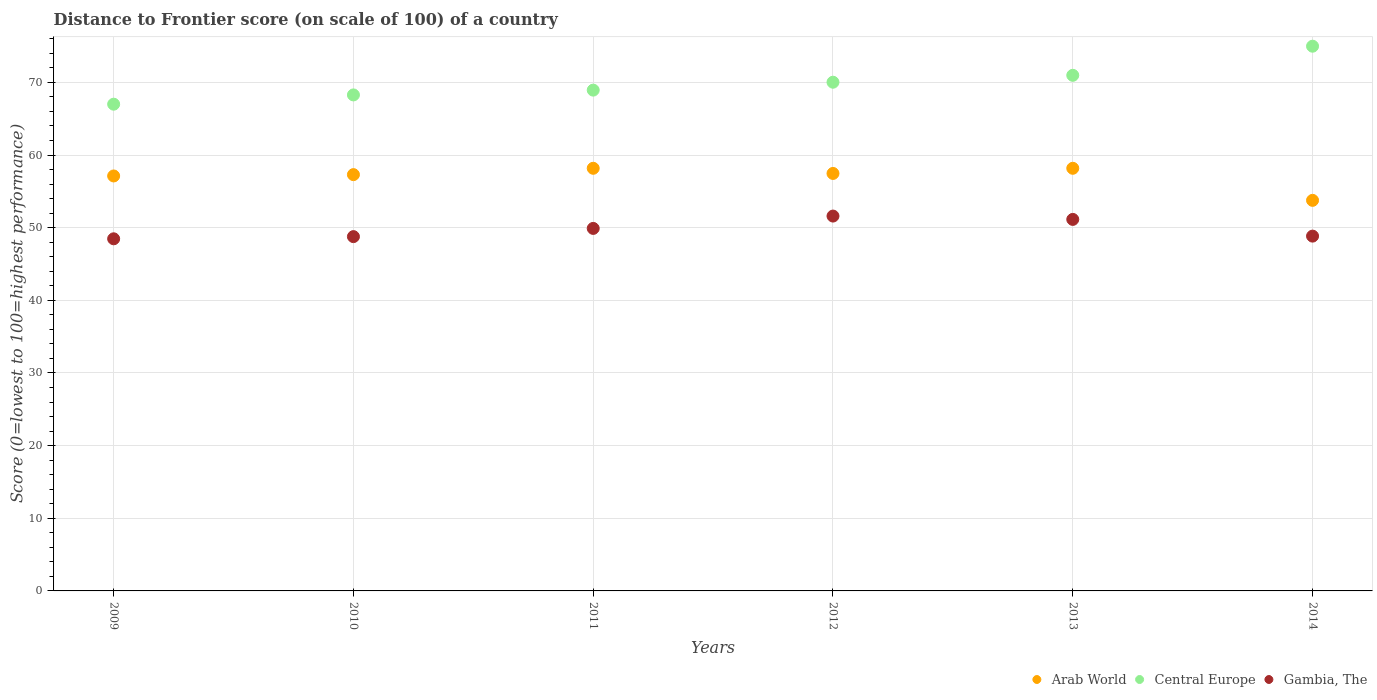How many different coloured dotlines are there?
Your answer should be very brief. 3. Is the number of dotlines equal to the number of legend labels?
Make the answer very short. Yes. What is the distance to frontier score of in Arab World in 2013?
Offer a terse response. 58.18. Across all years, what is the maximum distance to frontier score of in Central Europe?
Offer a very short reply. 74.98. Across all years, what is the minimum distance to frontier score of in Arab World?
Your answer should be very brief. 53.76. In which year was the distance to frontier score of in Central Europe minimum?
Make the answer very short. 2009. What is the total distance to frontier score of in Gambia, The in the graph?
Make the answer very short. 298.72. What is the difference between the distance to frontier score of in Central Europe in 2009 and that in 2012?
Your answer should be compact. -3.03. What is the difference between the distance to frontier score of in Arab World in 2014 and the distance to frontier score of in Gambia, The in 2009?
Offer a terse response. 5.29. What is the average distance to frontier score of in Arab World per year?
Provide a short and direct response. 57. In the year 2010, what is the difference between the distance to frontier score of in Central Europe and distance to frontier score of in Arab World?
Keep it short and to the point. 10.97. In how many years, is the distance to frontier score of in Central Europe greater than 20?
Provide a short and direct response. 6. What is the ratio of the distance to frontier score of in Arab World in 2009 to that in 2014?
Your answer should be compact. 1.06. Is the distance to frontier score of in Gambia, The in 2011 less than that in 2012?
Your answer should be very brief. Yes. What is the difference between the highest and the second highest distance to frontier score of in Arab World?
Provide a succinct answer. 0. What is the difference between the highest and the lowest distance to frontier score of in Gambia, The?
Make the answer very short. 3.13. Is it the case that in every year, the sum of the distance to frontier score of in Central Europe and distance to frontier score of in Gambia, The  is greater than the distance to frontier score of in Arab World?
Provide a succinct answer. Yes. What is the difference between two consecutive major ticks on the Y-axis?
Your response must be concise. 10. Are the values on the major ticks of Y-axis written in scientific E-notation?
Keep it short and to the point. No. How many legend labels are there?
Provide a succinct answer. 3. What is the title of the graph?
Give a very brief answer. Distance to Frontier score (on scale of 100) of a country. Does "Somalia" appear as one of the legend labels in the graph?
Offer a very short reply. No. What is the label or title of the X-axis?
Offer a very short reply. Years. What is the label or title of the Y-axis?
Your response must be concise. Score (0=lowest to 100=highest performance). What is the Score (0=lowest to 100=highest performance) in Arab World in 2009?
Offer a very short reply. 57.12. What is the Score (0=lowest to 100=highest performance) of Gambia, The in 2009?
Provide a short and direct response. 48.47. What is the Score (0=lowest to 100=highest performance) in Arab World in 2010?
Make the answer very short. 57.3. What is the Score (0=lowest to 100=highest performance) of Central Europe in 2010?
Keep it short and to the point. 68.28. What is the Score (0=lowest to 100=highest performance) in Gambia, The in 2010?
Your answer should be very brief. 48.77. What is the Score (0=lowest to 100=highest performance) of Arab World in 2011?
Your response must be concise. 58.18. What is the Score (0=lowest to 100=highest performance) of Central Europe in 2011?
Offer a terse response. 68.94. What is the Score (0=lowest to 100=highest performance) in Gambia, The in 2011?
Your response must be concise. 49.9. What is the Score (0=lowest to 100=highest performance) in Arab World in 2012?
Ensure brevity in your answer.  57.47. What is the Score (0=lowest to 100=highest performance) of Central Europe in 2012?
Ensure brevity in your answer.  70.03. What is the Score (0=lowest to 100=highest performance) in Gambia, The in 2012?
Your answer should be compact. 51.6. What is the Score (0=lowest to 100=highest performance) of Arab World in 2013?
Keep it short and to the point. 58.18. What is the Score (0=lowest to 100=highest performance) of Central Europe in 2013?
Give a very brief answer. 70.97. What is the Score (0=lowest to 100=highest performance) of Gambia, The in 2013?
Your answer should be very brief. 51.14. What is the Score (0=lowest to 100=highest performance) in Arab World in 2014?
Your response must be concise. 53.76. What is the Score (0=lowest to 100=highest performance) in Central Europe in 2014?
Ensure brevity in your answer.  74.98. What is the Score (0=lowest to 100=highest performance) of Gambia, The in 2014?
Give a very brief answer. 48.84. Across all years, what is the maximum Score (0=lowest to 100=highest performance) in Arab World?
Offer a very short reply. 58.18. Across all years, what is the maximum Score (0=lowest to 100=highest performance) in Central Europe?
Your response must be concise. 74.98. Across all years, what is the maximum Score (0=lowest to 100=highest performance) in Gambia, The?
Provide a short and direct response. 51.6. Across all years, what is the minimum Score (0=lowest to 100=highest performance) in Arab World?
Give a very brief answer. 53.76. Across all years, what is the minimum Score (0=lowest to 100=highest performance) in Central Europe?
Your answer should be compact. 67. Across all years, what is the minimum Score (0=lowest to 100=highest performance) of Gambia, The?
Offer a very short reply. 48.47. What is the total Score (0=lowest to 100=highest performance) in Arab World in the graph?
Your answer should be very brief. 342.01. What is the total Score (0=lowest to 100=highest performance) of Central Europe in the graph?
Offer a terse response. 420.19. What is the total Score (0=lowest to 100=highest performance) in Gambia, The in the graph?
Offer a very short reply. 298.72. What is the difference between the Score (0=lowest to 100=highest performance) of Arab World in 2009 and that in 2010?
Offer a terse response. -0.18. What is the difference between the Score (0=lowest to 100=highest performance) in Central Europe in 2009 and that in 2010?
Provide a short and direct response. -1.28. What is the difference between the Score (0=lowest to 100=highest performance) in Arab World in 2009 and that in 2011?
Offer a terse response. -1.06. What is the difference between the Score (0=lowest to 100=highest performance) in Central Europe in 2009 and that in 2011?
Provide a succinct answer. -1.94. What is the difference between the Score (0=lowest to 100=highest performance) of Gambia, The in 2009 and that in 2011?
Ensure brevity in your answer.  -1.43. What is the difference between the Score (0=lowest to 100=highest performance) in Arab World in 2009 and that in 2012?
Give a very brief answer. -0.35. What is the difference between the Score (0=lowest to 100=highest performance) of Central Europe in 2009 and that in 2012?
Offer a terse response. -3.03. What is the difference between the Score (0=lowest to 100=highest performance) in Gambia, The in 2009 and that in 2012?
Provide a short and direct response. -3.13. What is the difference between the Score (0=lowest to 100=highest performance) in Arab World in 2009 and that in 2013?
Ensure brevity in your answer.  -1.06. What is the difference between the Score (0=lowest to 100=highest performance) in Central Europe in 2009 and that in 2013?
Offer a very short reply. -3.97. What is the difference between the Score (0=lowest to 100=highest performance) in Gambia, The in 2009 and that in 2013?
Your response must be concise. -2.67. What is the difference between the Score (0=lowest to 100=highest performance) in Arab World in 2009 and that in 2014?
Offer a terse response. 3.36. What is the difference between the Score (0=lowest to 100=highest performance) in Central Europe in 2009 and that in 2014?
Give a very brief answer. -7.98. What is the difference between the Score (0=lowest to 100=highest performance) in Gambia, The in 2009 and that in 2014?
Your answer should be compact. -0.37. What is the difference between the Score (0=lowest to 100=highest performance) of Arab World in 2010 and that in 2011?
Provide a succinct answer. -0.87. What is the difference between the Score (0=lowest to 100=highest performance) of Central Europe in 2010 and that in 2011?
Ensure brevity in your answer.  -0.66. What is the difference between the Score (0=lowest to 100=highest performance) of Gambia, The in 2010 and that in 2011?
Keep it short and to the point. -1.13. What is the difference between the Score (0=lowest to 100=highest performance) of Arab World in 2010 and that in 2012?
Your answer should be very brief. -0.16. What is the difference between the Score (0=lowest to 100=highest performance) in Central Europe in 2010 and that in 2012?
Keep it short and to the point. -1.75. What is the difference between the Score (0=lowest to 100=highest performance) of Gambia, The in 2010 and that in 2012?
Keep it short and to the point. -2.83. What is the difference between the Score (0=lowest to 100=highest performance) in Arab World in 2010 and that in 2013?
Ensure brevity in your answer.  -0.87. What is the difference between the Score (0=lowest to 100=highest performance) in Central Europe in 2010 and that in 2013?
Your response must be concise. -2.7. What is the difference between the Score (0=lowest to 100=highest performance) in Gambia, The in 2010 and that in 2013?
Provide a succinct answer. -2.37. What is the difference between the Score (0=lowest to 100=highest performance) of Arab World in 2010 and that in 2014?
Keep it short and to the point. 3.54. What is the difference between the Score (0=lowest to 100=highest performance) of Central Europe in 2010 and that in 2014?
Your answer should be very brief. -6.71. What is the difference between the Score (0=lowest to 100=highest performance) of Gambia, The in 2010 and that in 2014?
Offer a terse response. -0.07. What is the difference between the Score (0=lowest to 100=highest performance) in Arab World in 2011 and that in 2012?
Offer a terse response. 0.71. What is the difference between the Score (0=lowest to 100=highest performance) of Central Europe in 2011 and that in 2012?
Give a very brief answer. -1.09. What is the difference between the Score (0=lowest to 100=highest performance) in Gambia, The in 2011 and that in 2012?
Your answer should be compact. -1.7. What is the difference between the Score (0=lowest to 100=highest performance) in Arab World in 2011 and that in 2013?
Give a very brief answer. 0. What is the difference between the Score (0=lowest to 100=highest performance) of Central Europe in 2011 and that in 2013?
Provide a short and direct response. -2.04. What is the difference between the Score (0=lowest to 100=highest performance) in Gambia, The in 2011 and that in 2013?
Your response must be concise. -1.24. What is the difference between the Score (0=lowest to 100=highest performance) of Arab World in 2011 and that in 2014?
Your answer should be very brief. 4.41. What is the difference between the Score (0=lowest to 100=highest performance) of Central Europe in 2011 and that in 2014?
Provide a succinct answer. -6.05. What is the difference between the Score (0=lowest to 100=highest performance) in Gambia, The in 2011 and that in 2014?
Your response must be concise. 1.06. What is the difference between the Score (0=lowest to 100=highest performance) in Arab World in 2012 and that in 2013?
Your answer should be compact. -0.71. What is the difference between the Score (0=lowest to 100=highest performance) of Central Europe in 2012 and that in 2013?
Your response must be concise. -0.95. What is the difference between the Score (0=lowest to 100=highest performance) in Gambia, The in 2012 and that in 2013?
Your response must be concise. 0.46. What is the difference between the Score (0=lowest to 100=highest performance) of Arab World in 2012 and that in 2014?
Your answer should be compact. 3.7. What is the difference between the Score (0=lowest to 100=highest performance) of Central Europe in 2012 and that in 2014?
Make the answer very short. -4.96. What is the difference between the Score (0=lowest to 100=highest performance) in Gambia, The in 2012 and that in 2014?
Offer a very short reply. 2.76. What is the difference between the Score (0=lowest to 100=highest performance) of Arab World in 2013 and that in 2014?
Ensure brevity in your answer.  4.41. What is the difference between the Score (0=lowest to 100=highest performance) in Central Europe in 2013 and that in 2014?
Offer a terse response. -4.01. What is the difference between the Score (0=lowest to 100=highest performance) in Gambia, The in 2013 and that in 2014?
Keep it short and to the point. 2.3. What is the difference between the Score (0=lowest to 100=highest performance) in Arab World in 2009 and the Score (0=lowest to 100=highest performance) in Central Europe in 2010?
Make the answer very short. -11.16. What is the difference between the Score (0=lowest to 100=highest performance) in Arab World in 2009 and the Score (0=lowest to 100=highest performance) in Gambia, The in 2010?
Your response must be concise. 8.35. What is the difference between the Score (0=lowest to 100=highest performance) of Central Europe in 2009 and the Score (0=lowest to 100=highest performance) of Gambia, The in 2010?
Your answer should be compact. 18.23. What is the difference between the Score (0=lowest to 100=highest performance) of Arab World in 2009 and the Score (0=lowest to 100=highest performance) of Central Europe in 2011?
Offer a terse response. -11.82. What is the difference between the Score (0=lowest to 100=highest performance) in Arab World in 2009 and the Score (0=lowest to 100=highest performance) in Gambia, The in 2011?
Offer a terse response. 7.22. What is the difference between the Score (0=lowest to 100=highest performance) of Arab World in 2009 and the Score (0=lowest to 100=highest performance) of Central Europe in 2012?
Make the answer very short. -12.9. What is the difference between the Score (0=lowest to 100=highest performance) in Arab World in 2009 and the Score (0=lowest to 100=highest performance) in Gambia, The in 2012?
Your response must be concise. 5.52. What is the difference between the Score (0=lowest to 100=highest performance) of Central Europe in 2009 and the Score (0=lowest to 100=highest performance) of Gambia, The in 2012?
Your response must be concise. 15.4. What is the difference between the Score (0=lowest to 100=highest performance) in Arab World in 2009 and the Score (0=lowest to 100=highest performance) in Central Europe in 2013?
Offer a terse response. -13.85. What is the difference between the Score (0=lowest to 100=highest performance) of Arab World in 2009 and the Score (0=lowest to 100=highest performance) of Gambia, The in 2013?
Your response must be concise. 5.98. What is the difference between the Score (0=lowest to 100=highest performance) of Central Europe in 2009 and the Score (0=lowest to 100=highest performance) of Gambia, The in 2013?
Give a very brief answer. 15.86. What is the difference between the Score (0=lowest to 100=highest performance) of Arab World in 2009 and the Score (0=lowest to 100=highest performance) of Central Europe in 2014?
Your response must be concise. -17.86. What is the difference between the Score (0=lowest to 100=highest performance) in Arab World in 2009 and the Score (0=lowest to 100=highest performance) in Gambia, The in 2014?
Provide a succinct answer. 8.28. What is the difference between the Score (0=lowest to 100=highest performance) of Central Europe in 2009 and the Score (0=lowest to 100=highest performance) of Gambia, The in 2014?
Provide a succinct answer. 18.16. What is the difference between the Score (0=lowest to 100=highest performance) of Arab World in 2010 and the Score (0=lowest to 100=highest performance) of Central Europe in 2011?
Make the answer very short. -11.63. What is the difference between the Score (0=lowest to 100=highest performance) in Arab World in 2010 and the Score (0=lowest to 100=highest performance) in Gambia, The in 2011?
Offer a terse response. 7.4. What is the difference between the Score (0=lowest to 100=highest performance) of Central Europe in 2010 and the Score (0=lowest to 100=highest performance) of Gambia, The in 2011?
Your answer should be very brief. 18.38. What is the difference between the Score (0=lowest to 100=highest performance) in Arab World in 2010 and the Score (0=lowest to 100=highest performance) in Central Europe in 2012?
Your response must be concise. -12.72. What is the difference between the Score (0=lowest to 100=highest performance) in Arab World in 2010 and the Score (0=lowest to 100=highest performance) in Gambia, The in 2012?
Your response must be concise. 5.7. What is the difference between the Score (0=lowest to 100=highest performance) in Central Europe in 2010 and the Score (0=lowest to 100=highest performance) in Gambia, The in 2012?
Offer a terse response. 16.68. What is the difference between the Score (0=lowest to 100=highest performance) of Arab World in 2010 and the Score (0=lowest to 100=highest performance) of Central Europe in 2013?
Ensure brevity in your answer.  -13.67. What is the difference between the Score (0=lowest to 100=highest performance) of Arab World in 2010 and the Score (0=lowest to 100=highest performance) of Gambia, The in 2013?
Ensure brevity in your answer.  6.16. What is the difference between the Score (0=lowest to 100=highest performance) in Central Europe in 2010 and the Score (0=lowest to 100=highest performance) in Gambia, The in 2013?
Your response must be concise. 17.14. What is the difference between the Score (0=lowest to 100=highest performance) of Arab World in 2010 and the Score (0=lowest to 100=highest performance) of Central Europe in 2014?
Provide a short and direct response. -17.68. What is the difference between the Score (0=lowest to 100=highest performance) in Arab World in 2010 and the Score (0=lowest to 100=highest performance) in Gambia, The in 2014?
Provide a succinct answer. 8.46. What is the difference between the Score (0=lowest to 100=highest performance) in Central Europe in 2010 and the Score (0=lowest to 100=highest performance) in Gambia, The in 2014?
Make the answer very short. 19.44. What is the difference between the Score (0=lowest to 100=highest performance) of Arab World in 2011 and the Score (0=lowest to 100=highest performance) of Central Europe in 2012?
Your answer should be compact. -11.85. What is the difference between the Score (0=lowest to 100=highest performance) of Arab World in 2011 and the Score (0=lowest to 100=highest performance) of Gambia, The in 2012?
Ensure brevity in your answer.  6.58. What is the difference between the Score (0=lowest to 100=highest performance) of Central Europe in 2011 and the Score (0=lowest to 100=highest performance) of Gambia, The in 2012?
Your answer should be very brief. 17.34. What is the difference between the Score (0=lowest to 100=highest performance) in Arab World in 2011 and the Score (0=lowest to 100=highest performance) in Central Europe in 2013?
Offer a terse response. -12.8. What is the difference between the Score (0=lowest to 100=highest performance) of Arab World in 2011 and the Score (0=lowest to 100=highest performance) of Gambia, The in 2013?
Your answer should be very brief. 7.04. What is the difference between the Score (0=lowest to 100=highest performance) in Central Europe in 2011 and the Score (0=lowest to 100=highest performance) in Gambia, The in 2013?
Provide a succinct answer. 17.8. What is the difference between the Score (0=lowest to 100=highest performance) in Arab World in 2011 and the Score (0=lowest to 100=highest performance) in Central Europe in 2014?
Your answer should be compact. -16.81. What is the difference between the Score (0=lowest to 100=highest performance) of Arab World in 2011 and the Score (0=lowest to 100=highest performance) of Gambia, The in 2014?
Keep it short and to the point. 9.34. What is the difference between the Score (0=lowest to 100=highest performance) in Central Europe in 2011 and the Score (0=lowest to 100=highest performance) in Gambia, The in 2014?
Your response must be concise. 20.1. What is the difference between the Score (0=lowest to 100=highest performance) in Arab World in 2012 and the Score (0=lowest to 100=highest performance) in Central Europe in 2013?
Give a very brief answer. -13.51. What is the difference between the Score (0=lowest to 100=highest performance) in Arab World in 2012 and the Score (0=lowest to 100=highest performance) in Gambia, The in 2013?
Provide a succinct answer. 6.33. What is the difference between the Score (0=lowest to 100=highest performance) of Central Europe in 2012 and the Score (0=lowest to 100=highest performance) of Gambia, The in 2013?
Provide a succinct answer. 18.89. What is the difference between the Score (0=lowest to 100=highest performance) in Arab World in 2012 and the Score (0=lowest to 100=highest performance) in Central Europe in 2014?
Keep it short and to the point. -17.52. What is the difference between the Score (0=lowest to 100=highest performance) of Arab World in 2012 and the Score (0=lowest to 100=highest performance) of Gambia, The in 2014?
Your answer should be compact. 8.63. What is the difference between the Score (0=lowest to 100=highest performance) of Central Europe in 2012 and the Score (0=lowest to 100=highest performance) of Gambia, The in 2014?
Keep it short and to the point. 21.19. What is the difference between the Score (0=lowest to 100=highest performance) of Arab World in 2013 and the Score (0=lowest to 100=highest performance) of Central Europe in 2014?
Keep it short and to the point. -16.81. What is the difference between the Score (0=lowest to 100=highest performance) in Arab World in 2013 and the Score (0=lowest to 100=highest performance) in Gambia, The in 2014?
Offer a terse response. 9.34. What is the difference between the Score (0=lowest to 100=highest performance) of Central Europe in 2013 and the Score (0=lowest to 100=highest performance) of Gambia, The in 2014?
Your answer should be compact. 22.13. What is the average Score (0=lowest to 100=highest performance) of Arab World per year?
Provide a short and direct response. 57. What is the average Score (0=lowest to 100=highest performance) in Central Europe per year?
Provide a succinct answer. 70.03. What is the average Score (0=lowest to 100=highest performance) of Gambia, The per year?
Give a very brief answer. 49.79. In the year 2009, what is the difference between the Score (0=lowest to 100=highest performance) in Arab World and Score (0=lowest to 100=highest performance) in Central Europe?
Keep it short and to the point. -9.88. In the year 2009, what is the difference between the Score (0=lowest to 100=highest performance) of Arab World and Score (0=lowest to 100=highest performance) of Gambia, The?
Provide a succinct answer. 8.65. In the year 2009, what is the difference between the Score (0=lowest to 100=highest performance) in Central Europe and Score (0=lowest to 100=highest performance) in Gambia, The?
Give a very brief answer. 18.53. In the year 2010, what is the difference between the Score (0=lowest to 100=highest performance) in Arab World and Score (0=lowest to 100=highest performance) in Central Europe?
Ensure brevity in your answer.  -10.97. In the year 2010, what is the difference between the Score (0=lowest to 100=highest performance) of Arab World and Score (0=lowest to 100=highest performance) of Gambia, The?
Provide a succinct answer. 8.53. In the year 2010, what is the difference between the Score (0=lowest to 100=highest performance) of Central Europe and Score (0=lowest to 100=highest performance) of Gambia, The?
Provide a short and direct response. 19.51. In the year 2011, what is the difference between the Score (0=lowest to 100=highest performance) of Arab World and Score (0=lowest to 100=highest performance) of Central Europe?
Provide a succinct answer. -10.76. In the year 2011, what is the difference between the Score (0=lowest to 100=highest performance) of Arab World and Score (0=lowest to 100=highest performance) of Gambia, The?
Your answer should be very brief. 8.28. In the year 2011, what is the difference between the Score (0=lowest to 100=highest performance) of Central Europe and Score (0=lowest to 100=highest performance) of Gambia, The?
Provide a short and direct response. 19.04. In the year 2012, what is the difference between the Score (0=lowest to 100=highest performance) of Arab World and Score (0=lowest to 100=highest performance) of Central Europe?
Your response must be concise. -12.56. In the year 2012, what is the difference between the Score (0=lowest to 100=highest performance) in Arab World and Score (0=lowest to 100=highest performance) in Gambia, The?
Make the answer very short. 5.87. In the year 2012, what is the difference between the Score (0=lowest to 100=highest performance) in Central Europe and Score (0=lowest to 100=highest performance) in Gambia, The?
Keep it short and to the point. 18.43. In the year 2013, what is the difference between the Score (0=lowest to 100=highest performance) in Arab World and Score (0=lowest to 100=highest performance) in Central Europe?
Ensure brevity in your answer.  -12.8. In the year 2013, what is the difference between the Score (0=lowest to 100=highest performance) of Arab World and Score (0=lowest to 100=highest performance) of Gambia, The?
Keep it short and to the point. 7.04. In the year 2013, what is the difference between the Score (0=lowest to 100=highest performance) in Central Europe and Score (0=lowest to 100=highest performance) in Gambia, The?
Provide a succinct answer. 19.83. In the year 2014, what is the difference between the Score (0=lowest to 100=highest performance) in Arab World and Score (0=lowest to 100=highest performance) in Central Europe?
Offer a terse response. -21.22. In the year 2014, what is the difference between the Score (0=lowest to 100=highest performance) of Arab World and Score (0=lowest to 100=highest performance) of Gambia, The?
Give a very brief answer. 4.92. In the year 2014, what is the difference between the Score (0=lowest to 100=highest performance) of Central Europe and Score (0=lowest to 100=highest performance) of Gambia, The?
Provide a short and direct response. 26.14. What is the ratio of the Score (0=lowest to 100=highest performance) in Central Europe in 2009 to that in 2010?
Your answer should be compact. 0.98. What is the ratio of the Score (0=lowest to 100=highest performance) in Arab World in 2009 to that in 2011?
Offer a very short reply. 0.98. What is the ratio of the Score (0=lowest to 100=highest performance) in Central Europe in 2009 to that in 2011?
Your response must be concise. 0.97. What is the ratio of the Score (0=lowest to 100=highest performance) in Gambia, The in 2009 to that in 2011?
Make the answer very short. 0.97. What is the ratio of the Score (0=lowest to 100=highest performance) of Arab World in 2009 to that in 2012?
Give a very brief answer. 0.99. What is the ratio of the Score (0=lowest to 100=highest performance) of Central Europe in 2009 to that in 2012?
Your response must be concise. 0.96. What is the ratio of the Score (0=lowest to 100=highest performance) in Gambia, The in 2009 to that in 2012?
Your response must be concise. 0.94. What is the ratio of the Score (0=lowest to 100=highest performance) in Arab World in 2009 to that in 2013?
Your answer should be compact. 0.98. What is the ratio of the Score (0=lowest to 100=highest performance) of Central Europe in 2009 to that in 2013?
Provide a succinct answer. 0.94. What is the ratio of the Score (0=lowest to 100=highest performance) of Gambia, The in 2009 to that in 2013?
Provide a short and direct response. 0.95. What is the ratio of the Score (0=lowest to 100=highest performance) of Arab World in 2009 to that in 2014?
Give a very brief answer. 1.06. What is the ratio of the Score (0=lowest to 100=highest performance) of Central Europe in 2009 to that in 2014?
Ensure brevity in your answer.  0.89. What is the ratio of the Score (0=lowest to 100=highest performance) of Arab World in 2010 to that in 2011?
Keep it short and to the point. 0.98. What is the ratio of the Score (0=lowest to 100=highest performance) in Gambia, The in 2010 to that in 2011?
Give a very brief answer. 0.98. What is the ratio of the Score (0=lowest to 100=highest performance) of Arab World in 2010 to that in 2012?
Your response must be concise. 1. What is the ratio of the Score (0=lowest to 100=highest performance) in Gambia, The in 2010 to that in 2012?
Your response must be concise. 0.95. What is the ratio of the Score (0=lowest to 100=highest performance) in Arab World in 2010 to that in 2013?
Provide a succinct answer. 0.98. What is the ratio of the Score (0=lowest to 100=highest performance) in Central Europe in 2010 to that in 2013?
Offer a terse response. 0.96. What is the ratio of the Score (0=lowest to 100=highest performance) of Gambia, The in 2010 to that in 2013?
Make the answer very short. 0.95. What is the ratio of the Score (0=lowest to 100=highest performance) of Arab World in 2010 to that in 2014?
Your response must be concise. 1.07. What is the ratio of the Score (0=lowest to 100=highest performance) in Central Europe in 2010 to that in 2014?
Make the answer very short. 0.91. What is the ratio of the Score (0=lowest to 100=highest performance) of Arab World in 2011 to that in 2012?
Give a very brief answer. 1.01. What is the ratio of the Score (0=lowest to 100=highest performance) of Central Europe in 2011 to that in 2012?
Ensure brevity in your answer.  0.98. What is the ratio of the Score (0=lowest to 100=highest performance) in Gambia, The in 2011 to that in 2012?
Ensure brevity in your answer.  0.97. What is the ratio of the Score (0=lowest to 100=highest performance) of Arab World in 2011 to that in 2013?
Offer a very short reply. 1. What is the ratio of the Score (0=lowest to 100=highest performance) in Central Europe in 2011 to that in 2013?
Your answer should be compact. 0.97. What is the ratio of the Score (0=lowest to 100=highest performance) in Gambia, The in 2011 to that in 2013?
Provide a short and direct response. 0.98. What is the ratio of the Score (0=lowest to 100=highest performance) of Arab World in 2011 to that in 2014?
Offer a very short reply. 1.08. What is the ratio of the Score (0=lowest to 100=highest performance) in Central Europe in 2011 to that in 2014?
Give a very brief answer. 0.92. What is the ratio of the Score (0=lowest to 100=highest performance) in Gambia, The in 2011 to that in 2014?
Keep it short and to the point. 1.02. What is the ratio of the Score (0=lowest to 100=highest performance) of Arab World in 2012 to that in 2013?
Offer a very short reply. 0.99. What is the ratio of the Score (0=lowest to 100=highest performance) of Central Europe in 2012 to that in 2013?
Make the answer very short. 0.99. What is the ratio of the Score (0=lowest to 100=highest performance) of Gambia, The in 2012 to that in 2013?
Make the answer very short. 1.01. What is the ratio of the Score (0=lowest to 100=highest performance) of Arab World in 2012 to that in 2014?
Your answer should be very brief. 1.07. What is the ratio of the Score (0=lowest to 100=highest performance) in Central Europe in 2012 to that in 2014?
Your answer should be very brief. 0.93. What is the ratio of the Score (0=lowest to 100=highest performance) in Gambia, The in 2012 to that in 2014?
Provide a short and direct response. 1.06. What is the ratio of the Score (0=lowest to 100=highest performance) in Arab World in 2013 to that in 2014?
Keep it short and to the point. 1.08. What is the ratio of the Score (0=lowest to 100=highest performance) of Central Europe in 2013 to that in 2014?
Provide a succinct answer. 0.95. What is the ratio of the Score (0=lowest to 100=highest performance) in Gambia, The in 2013 to that in 2014?
Your response must be concise. 1.05. What is the difference between the highest and the second highest Score (0=lowest to 100=highest performance) in Arab World?
Give a very brief answer. 0. What is the difference between the highest and the second highest Score (0=lowest to 100=highest performance) of Central Europe?
Give a very brief answer. 4.01. What is the difference between the highest and the second highest Score (0=lowest to 100=highest performance) of Gambia, The?
Offer a very short reply. 0.46. What is the difference between the highest and the lowest Score (0=lowest to 100=highest performance) in Arab World?
Give a very brief answer. 4.41. What is the difference between the highest and the lowest Score (0=lowest to 100=highest performance) of Central Europe?
Ensure brevity in your answer.  7.98. What is the difference between the highest and the lowest Score (0=lowest to 100=highest performance) in Gambia, The?
Keep it short and to the point. 3.13. 